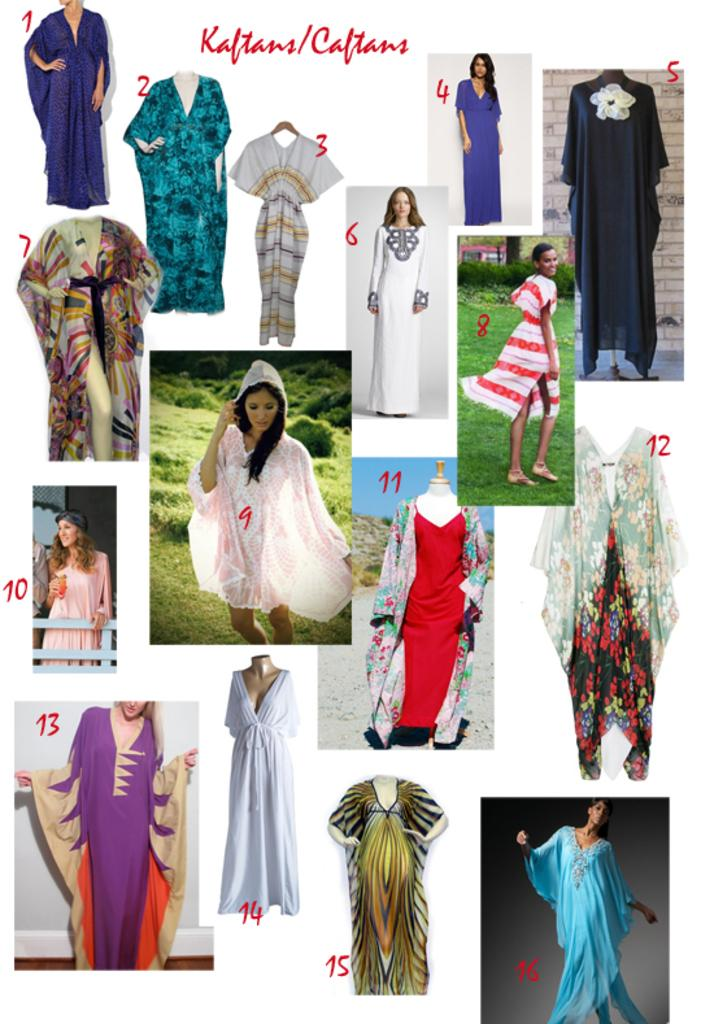What can be seen in the image related to a woman's clothing? There are different types of costumes for a woman in the image. How are the costumes organized or identified? The costumes are labelled with numbers. What else is visible in the image besides the costumes? There is some text visible in the image. What type of punishment is being depicted in the image? There is no punishment being depicted in the image; it features different types of costumes for a woman. Can you tell me how many baseballs are visible in the image? There are no baseballs present in the image. 